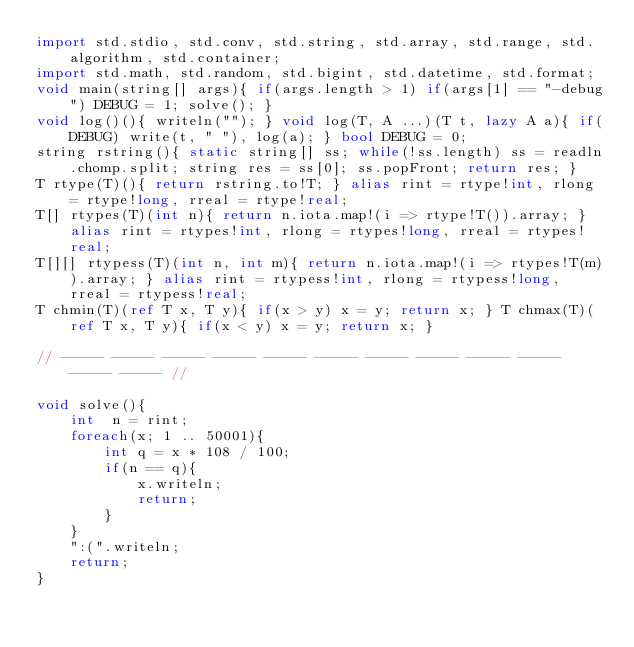Convert code to text. <code><loc_0><loc_0><loc_500><loc_500><_D_>import std.stdio, std.conv, std.string, std.array, std.range, std.algorithm, std.container;
import std.math, std.random, std.bigint, std.datetime, std.format;
void main(string[] args){ if(args.length > 1) if(args[1] == "-debug") DEBUG = 1; solve(); }
void log()(){ writeln(""); } void log(T, A ...)(T t, lazy A a){ if(DEBUG) write(t, " "), log(a); } bool DEBUG = 0; 
string rstring(){ static string[] ss; while(!ss.length) ss = readln.chomp.split; string res = ss[0]; ss.popFront; return res; }
T rtype(T)(){ return rstring.to!T; } alias rint = rtype!int, rlong = rtype!long, rreal = rtype!real;
T[] rtypes(T)(int n){ return n.iota.map!(i => rtype!T()).array; } alias rint = rtypes!int, rlong = rtypes!long, rreal = rtypes!real;
T[][] rtypess(T)(int n, int m){ return n.iota.map!(i => rtypes!T(m)).array; } alias rint = rtypess!int, rlong = rtypess!long, rreal = rtypess!real;
T chmin(T)(ref T x, T y){ if(x > y) x = y; return x; } T chmax(T)(ref T x, T y){ if(x < y) x = y; return x; }

// ----- ----- ----- ----- ----- ----- ----- ----- ----- ----- ----- ----- //

void solve(){
	int  n = rint;
	foreach(x; 1 .. 50001){
		int q = x * 108 / 100;
		if(n == q){
			x.writeln;
			return;
		}
	}
	":(".writeln;
	return;
}</code> 